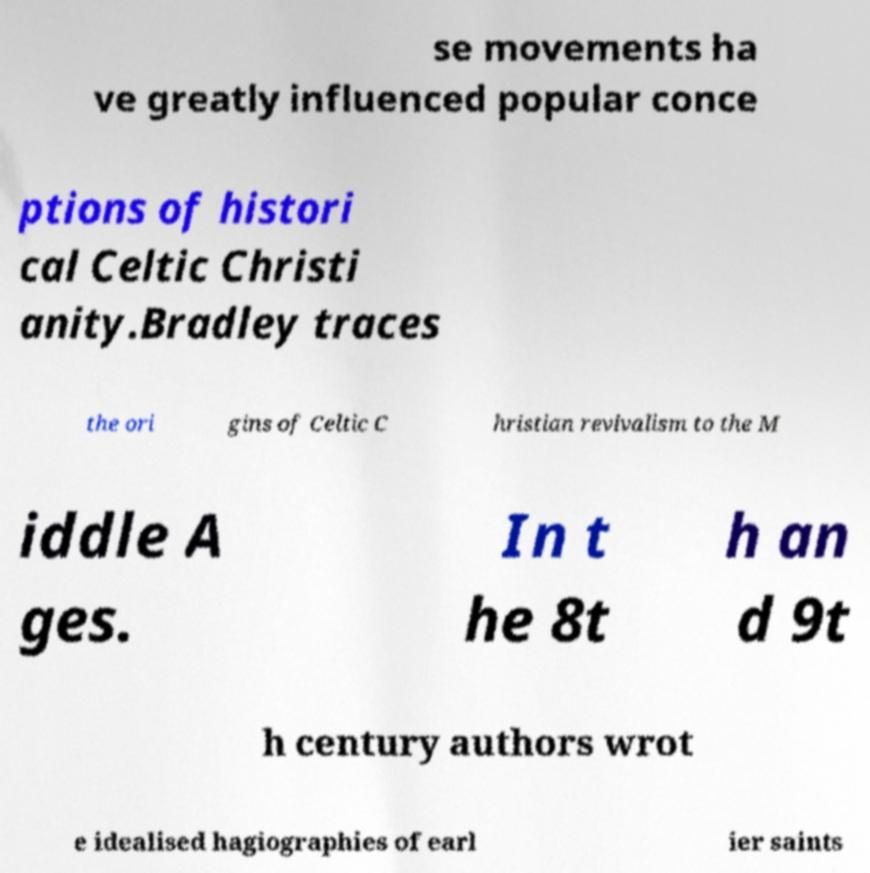There's text embedded in this image that I need extracted. Can you transcribe it verbatim? se movements ha ve greatly influenced popular conce ptions of histori cal Celtic Christi anity.Bradley traces the ori gins of Celtic C hristian revivalism to the M iddle A ges. In t he 8t h an d 9t h century authors wrot e idealised hagiographies of earl ier saints 